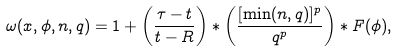<formula> <loc_0><loc_0><loc_500><loc_500>\omega ( x , \phi , n , q ) = 1 + \left ( \frac { \tau - t } { t - R } \right ) * \left ( \frac { [ \min ( n , q ) ] ^ { p } } { q ^ { p } } \right ) * F ( \phi ) ,</formula> 